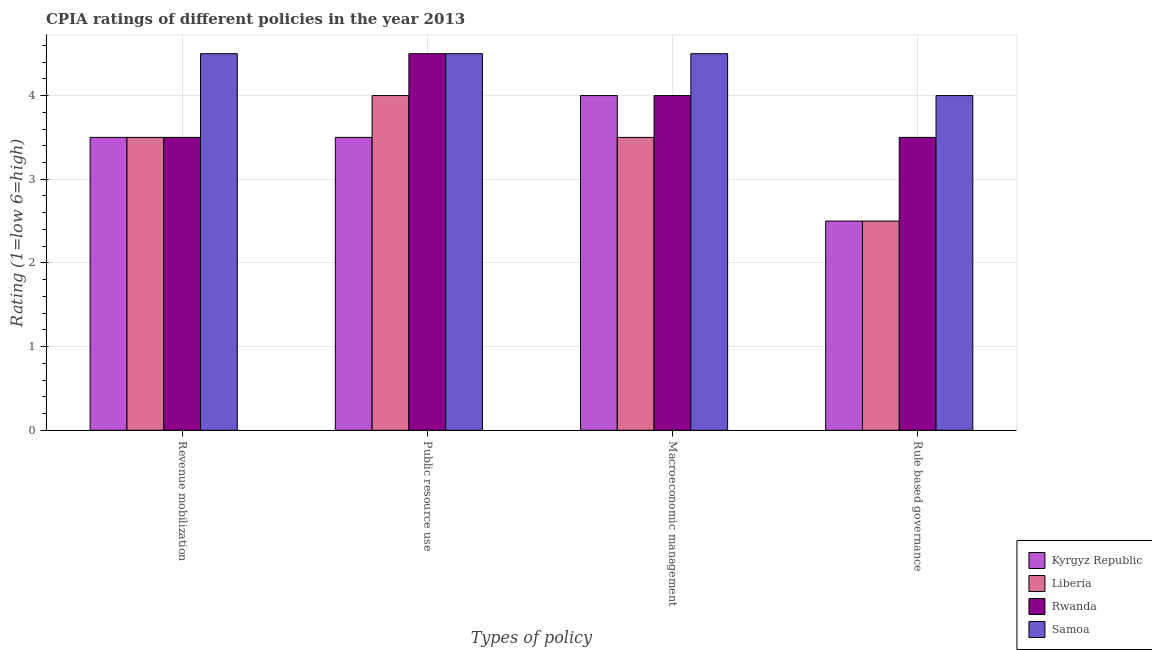Are the number of bars on each tick of the X-axis equal?
Your response must be concise. Yes. What is the label of the 1st group of bars from the left?
Your answer should be compact. Revenue mobilization. What is the cpia rating of macroeconomic management in Samoa?
Provide a succinct answer. 4.5. In which country was the cpia rating of macroeconomic management maximum?
Keep it short and to the point. Samoa. In which country was the cpia rating of rule based governance minimum?
Ensure brevity in your answer.  Kyrgyz Republic. What is the difference between the cpia rating of macroeconomic management in Kyrgyz Republic and that in Samoa?
Ensure brevity in your answer.  -0.5. What is the average cpia rating of revenue mobilization per country?
Your answer should be very brief. 3.75. What is the difference between the cpia rating of public resource use and cpia rating of revenue mobilization in Samoa?
Your response must be concise. 0. In how many countries, is the cpia rating of revenue mobilization greater than 4 ?
Your answer should be very brief. 1. What is the ratio of the cpia rating of rule based governance in Kyrgyz Republic to that in Samoa?
Your answer should be compact. 0.62. Is the difference between the cpia rating of macroeconomic management in Liberia and Samoa greater than the difference between the cpia rating of public resource use in Liberia and Samoa?
Make the answer very short. No. What is the difference between the highest and the second highest cpia rating of revenue mobilization?
Keep it short and to the point. 1. What is the difference between the highest and the lowest cpia rating of revenue mobilization?
Offer a very short reply. 1. Is the sum of the cpia rating of public resource use in Rwanda and Samoa greater than the maximum cpia rating of macroeconomic management across all countries?
Provide a succinct answer. Yes. What does the 4th bar from the left in Public resource use represents?
Your response must be concise. Samoa. What does the 4th bar from the right in Revenue mobilization represents?
Give a very brief answer. Kyrgyz Republic. How many bars are there?
Ensure brevity in your answer.  16. What is the difference between two consecutive major ticks on the Y-axis?
Make the answer very short. 1. Does the graph contain any zero values?
Provide a succinct answer. No. Where does the legend appear in the graph?
Your answer should be very brief. Bottom right. How many legend labels are there?
Ensure brevity in your answer.  4. What is the title of the graph?
Provide a short and direct response. CPIA ratings of different policies in the year 2013. What is the label or title of the X-axis?
Give a very brief answer. Types of policy. What is the label or title of the Y-axis?
Your answer should be compact. Rating (1=low 6=high). What is the Rating (1=low 6=high) in Liberia in Revenue mobilization?
Your answer should be compact. 3.5. What is the Rating (1=low 6=high) in Rwanda in Revenue mobilization?
Provide a succinct answer. 3.5. What is the Rating (1=low 6=high) in Samoa in Revenue mobilization?
Your answer should be very brief. 4.5. What is the Rating (1=low 6=high) in Kyrgyz Republic in Public resource use?
Provide a succinct answer. 3.5. What is the Rating (1=low 6=high) in Rwanda in Macroeconomic management?
Give a very brief answer. 4. What is the Rating (1=low 6=high) of Samoa in Macroeconomic management?
Give a very brief answer. 4.5. What is the Rating (1=low 6=high) in Kyrgyz Republic in Rule based governance?
Give a very brief answer. 2.5. What is the Rating (1=low 6=high) of Rwanda in Rule based governance?
Provide a short and direct response. 3.5. What is the Rating (1=low 6=high) in Samoa in Rule based governance?
Offer a very short reply. 4. Across all Types of policy, what is the maximum Rating (1=low 6=high) of Rwanda?
Your response must be concise. 4.5. Across all Types of policy, what is the maximum Rating (1=low 6=high) in Samoa?
Your answer should be compact. 4.5. Across all Types of policy, what is the minimum Rating (1=low 6=high) of Kyrgyz Republic?
Your answer should be very brief. 2.5. Across all Types of policy, what is the minimum Rating (1=low 6=high) of Liberia?
Your response must be concise. 2.5. Across all Types of policy, what is the minimum Rating (1=low 6=high) of Rwanda?
Provide a short and direct response. 3.5. What is the total Rating (1=low 6=high) in Rwanda in the graph?
Offer a terse response. 15.5. What is the total Rating (1=low 6=high) of Samoa in the graph?
Offer a very short reply. 17.5. What is the difference between the Rating (1=low 6=high) in Kyrgyz Republic in Revenue mobilization and that in Public resource use?
Offer a terse response. 0. What is the difference between the Rating (1=low 6=high) of Rwanda in Revenue mobilization and that in Public resource use?
Offer a terse response. -1. What is the difference between the Rating (1=low 6=high) in Kyrgyz Republic in Revenue mobilization and that in Macroeconomic management?
Your response must be concise. -0.5. What is the difference between the Rating (1=low 6=high) of Liberia in Revenue mobilization and that in Macroeconomic management?
Provide a succinct answer. 0. What is the difference between the Rating (1=low 6=high) in Rwanda in Revenue mobilization and that in Macroeconomic management?
Offer a very short reply. -0.5. What is the difference between the Rating (1=low 6=high) in Kyrgyz Republic in Revenue mobilization and that in Rule based governance?
Give a very brief answer. 1. What is the difference between the Rating (1=low 6=high) of Liberia in Revenue mobilization and that in Rule based governance?
Make the answer very short. 1. What is the difference between the Rating (1=low 6=high) in Samoa in Revenue mobilization and that in Rule based governance?
Make the answer very short. 0.5. What is the difference between the Rating (1=low 6=high) of Liberia in Public resource use and that in Rule based governance?
Your answer should be very brief. 1.5. What is the difference between the Rating (1=low 6=high) in Rwanda in Public resource use and that in Rule based governance?
Make the answer very short. 1. What is the difference between the Rating (1=low 6=high) of Liberia in Macroeconomic management and that in Rule based governance?
Your answer should be compact. 1. What is the difference between the Rating (1=low 6=high) in Samoa in Macroeconomic management and that in Rule based governance?
Ensure brevity in your answer.  0.5. What is the difference between the Rating (1=low 6=high) in Kyrgyz Republic in Revenue mobilization and the Rating (1=low 6=high) in Liberia in Public resource use?
Make the answer very short. -0.5. What is the difference between the Rating (1=low 6=high) of Kyrgyz Republic in Revenue mobilization and the Rating (1=low 6=high) of Rwanda in Public resource use?
Offer a very short reply. -1. What is the difference between the Rating (1=low 6=high) of Kyrgyz Republic in Revenue mobilization and the Rating (1=low 6=high) of Samoa in Public resource use?
Your answer should be compact. -1. What is the difference between the Rating (1=low 6=high) of Liberia in Revenue mobilization and the Rating (1=low 6=high) of Samoa in Public resource use?
Make the answer very short. -1. What is the difference between the Rating (1=low 6=high) in Rwanda in Revenue mobilization and the Rating (1=low 6=high) in Samoa in Public resource use?
Your answer should be compact. -1. What is the difference between the Rating (1=low 6=high) in Kyrgyz Republic in Revenue mobilization and the Rating (1=low 6=high) in Liberia in Macroeconomic management?
Your answer should be very brief. 0. What is the difference between the Rating (1=low 6=high) in Kyrgyz Republic in Revenue mobilization and the Rating (1=low 6=high) in Rwanda in Macroeconomic management?
Provide a short and direct response. -0.5. What is the difference between the Rating (1=low 6=high) in Liberia in Revenue mobilization and the Rating (1=low 6=high) in Rwanda in Macroeconomic management?
Offer a very short reply. -0.5. What is the difference between the Rating (1=low 6=high) in Rwanda in Revenue mobilization and the Rating (1=low 6=high) in Samoa in Macroeconomic management?
Provide a short and direct response. -1. What is the difference between the Rating (1=low 6=high) of Kyrgyz Republic in Revenue mobilization and the Rating (1=low 6=high) of Liberia in Rule based governance?
Your answer should be very brief. 1. What is the difference between the Rating (1=low 6=high) in Rwanda in Revenue mobilization and the Rating (1=low 6=high) in Samoa in Rule based governance?
Offer a very short reply. -0.5. What is the difference between the Rating (1=low 6=high) of Kyrgyz Republic in Public resource use and the Rating (1=low 6=high) of Rwanda in Macroeconomic management?
Your answer should be compact. -0.5. What is the difference between the Rating (1=low 6=high) in Kyrgyz Republic in Public resource use and the Rating (1=low 6=high) in Samoa in Macroeconomic management?
Your response must be concise. -1. What is the difference between the Rating (1=low 6=high) in Liberia in Public resource use and the Rating (1=low 6=high) in Rwanda in Macroeconomic management?
Keep it short and to the point. 0. What is the difference between the Rating (1=low 6=high) of Rwanda in Public resource use and the Rating (1=low 6=high) of Samoa in Macroeconomic management?
Ensure brevity in your answer.  0. What is the difference between the Rating (1=low 6=high) in Kyrgyz Republic in Public resource use and the Rating (1=low 6=high) in Rwanda in Rule based governance?
Keep it short and to the point. 0. What is the difference between the Rating (1=low 6=high) in Kyrgyz Republic in Public resource use and the Rating (1=low 6=high) in Samoa in Rule based governance?
Keep it short and to the point. -0.5. What is the difference between the Rating (1=low 6=high) in Liberia in Public resource use and the Rating (1=low 6=high) in Rwanda in Rule based governance?
Your response must be concise. 0.5. What is the difference between the Rating (1=low 6=high) of Liberia in Macroeconomic management and the Rating (1=low 6=high) of Samoa in Rule based governance?
Give a very brief answer. -0.5. What is the difference between the Rating (1=low 6=high) of Rwanda in Macroeconomic management and the Rating (1=low 6=high) of Samoa in Rule based governance?
Your answer should be very brief. 0. What is the average Rating (1=low 6=high) in Kyrgyz Republic per Types of policy?
Ensure brevity in your answer.  3.38. What is the average Rating (1=low 6=high) in Liberia per Types of policy?
Offer a terse response. 3.38. What is the average Rating (1=low 6=high) in Rwanda per Types of policy?
Your answer should be very brief. 3.88. What is the average Rating (1=low 6=high) of Samoa per Types of policy?
Give a very brief answer. 4.38. What is the difference between the Rating (1=low 6=high) of Kyrgyz Republic and Rating (1=low 6=high) of Liberia in Revenue mobilization?
Give a very brief answer. 0. What is the difference between the Rating (1=low 6=high) of Kyrgyz Republic and Rating (1=low 6=high) of Samoa in Revenue mobilization?
Keep it short and to the point. -1. What is the difference between the Rating (1=low 6=high) in Liberia and Rating (1=low 6=high) in Rwanda in Revenue mobilization?
Your answer should be very brief. 0. What is the difference between the Rating (1=low 6=high) of Rwanda and Rating (1=low 6=high) of Samoa in Revenue mobilization?
Your answer should be compact. -1. What is the difference between the Rating (1=low 6=high) in Kyrgyz Republic and Rating (1=low 6=high) in Rwanda in Public resource use?
Ensure brevity in your answer.  -1. What is the difference between the Rating (1=low 6=high) in Kyrgyz Republic and Rating (1=low 6=high) in Samoa in Public resource use?
Give a very brief answer. -1. What is the difference between the Rating (1=low 6=high) in Rwanda and Rating (1=low 6=high) in Samoa in Public resource use?
Provide a succinct answer. 0. What is the difference between the Rating (1=low 6=high) of Liberia and Rating (1=low 6=high) of Samoa in Macroeconomic management?
Give a very brief answer. -1. What is the difference between the Rating (1=low 6=high) in Kyrgyz Republic and Rating (1=low 6=high) in Liberia in Rule based governance?
Your answer should be compact. 0. What is the difference between the Rating (1=low 6=high) in Kyrgyz Republic and Rating (1=low 6=high) in Rwanda in Rule based governance?
Your answer should be compact. -1. What is the difference between the Rating (1=low 6=high) of Kyrgyz Republic and Rating (1=low 6=high) of Samoa in Rule based governance?
Keep it short and to the point. -1.5. What is the difference between the Rating (1=low 6=high) in Liberia and Rating (1=low 6=high) in Rwanda in Rule based governance?
Keep it short and to the point. -1. What is the difference between the Rating (1=low 6=high) in Liberia and Rating (1=low 6=high) in Samoa in Rule based governance?
Your response must be concise. -1.5. What is the difference between the Rating (1=low 6=high) of Rwanda and Rating (1=low 6=high) of Samoa in Rule based governance?
Your response must be concise. -0.5. What is the ratio of the Rating (1=low 6=high) in Liberia in Revenue mobilization to that in Public resource use?
Ensure brevity in your answer.  0.88. What is the ratio of the Rating (1=low 6=high) in Kyrgyz Republic in Revenue mobilization to that in Rule based governance?
Your answer should be very brief. 1.4. What is the ratio of the Rating (1=low 6=high) of Liberia in Revenue mobilization to that in Rule based governance?
Keep it short and to the point. 1.4. What is the ratio of the Rating (1=low 6=high) in Rwanda in Revenue mobilization to that in Rule based governance?
Offer a terse response. 1. What is the ratio of the Rating (1=low 6=high) in Kyrgyz Republic in Public resource use to that in Rule based governance?
Your answer should be very brief. 1.4. What is the ratio of the Rating (1=low 6=high) of Liberia in Public resource use to that in Rule based governance?
Make the answer very short. 1.6. What is the ratio of the Rating (1=low 6=high) of Rwanda in Public resource use to that in Rule based governance?
Your response must be concise. 1.29. What is the ratio of the Rating (1=low 6=high) in Samoa in Public resource use to that in Rule based governance?
Your answer should be very brief. 1.12. What is the ratio of the Rating (1=low 6=high) in Samoa in Macroeconomic management to that in Rule based governance?
Ensure brevity in your answer.  1.12. What is the difference between the highest and the second highest Rating (1=low 6=high) of Liberia?
Provide a succinct answer. 0.5. What is the difference between the highest and the lowest Rating (1=low 6=high) in Liberia?
Provide a succinct answer. 1.5. What is the difference between the highest and the lowest Rating (1=low 6=high) of Rwanda?
Keep it short and to the point. 1. 